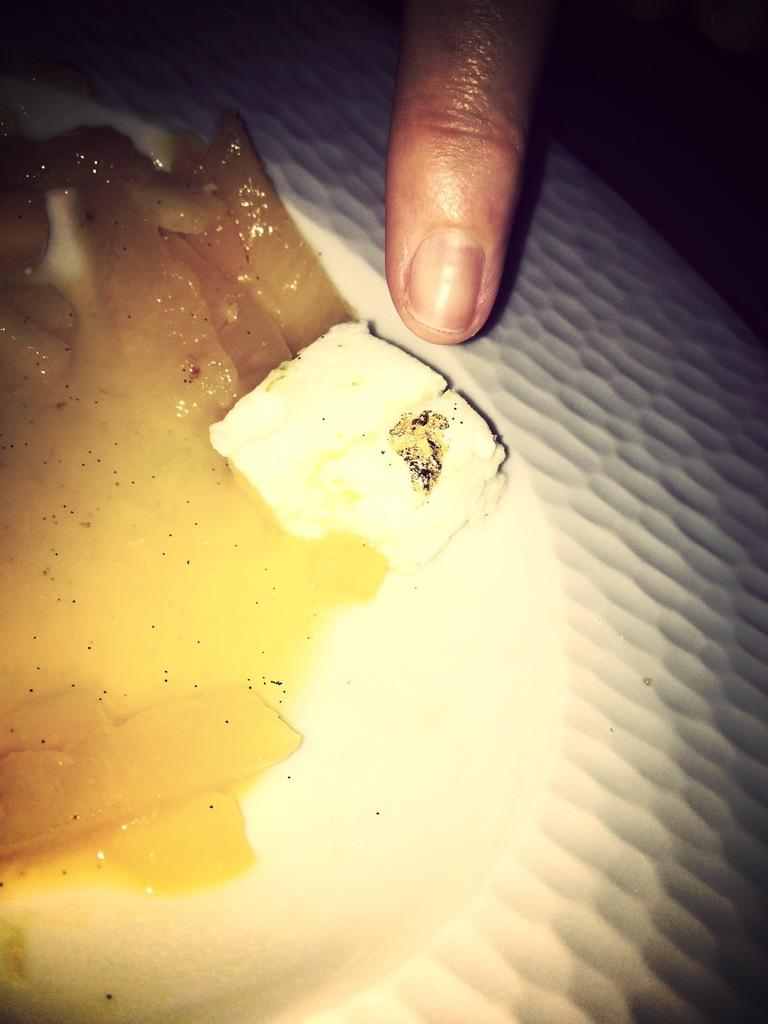What type of food is visible in the image? There is a part of a boiled egg in the image. What is the color of the boiled egg? The boiled egg has a yellow color. Is there any other object or person's body part touching the boiled egg? Yes, a person's finger is on the boiled egg. How many kittens are playing around the boiled egg in the image? There are no kittens present in the image. What is the cause of death for the person whose finger is on the boiled egg in the image? There is no indication of death or any related information in the image. Is there any evidence of war or conflict in the image? No, there is no evidence of war or conflict in the image. 